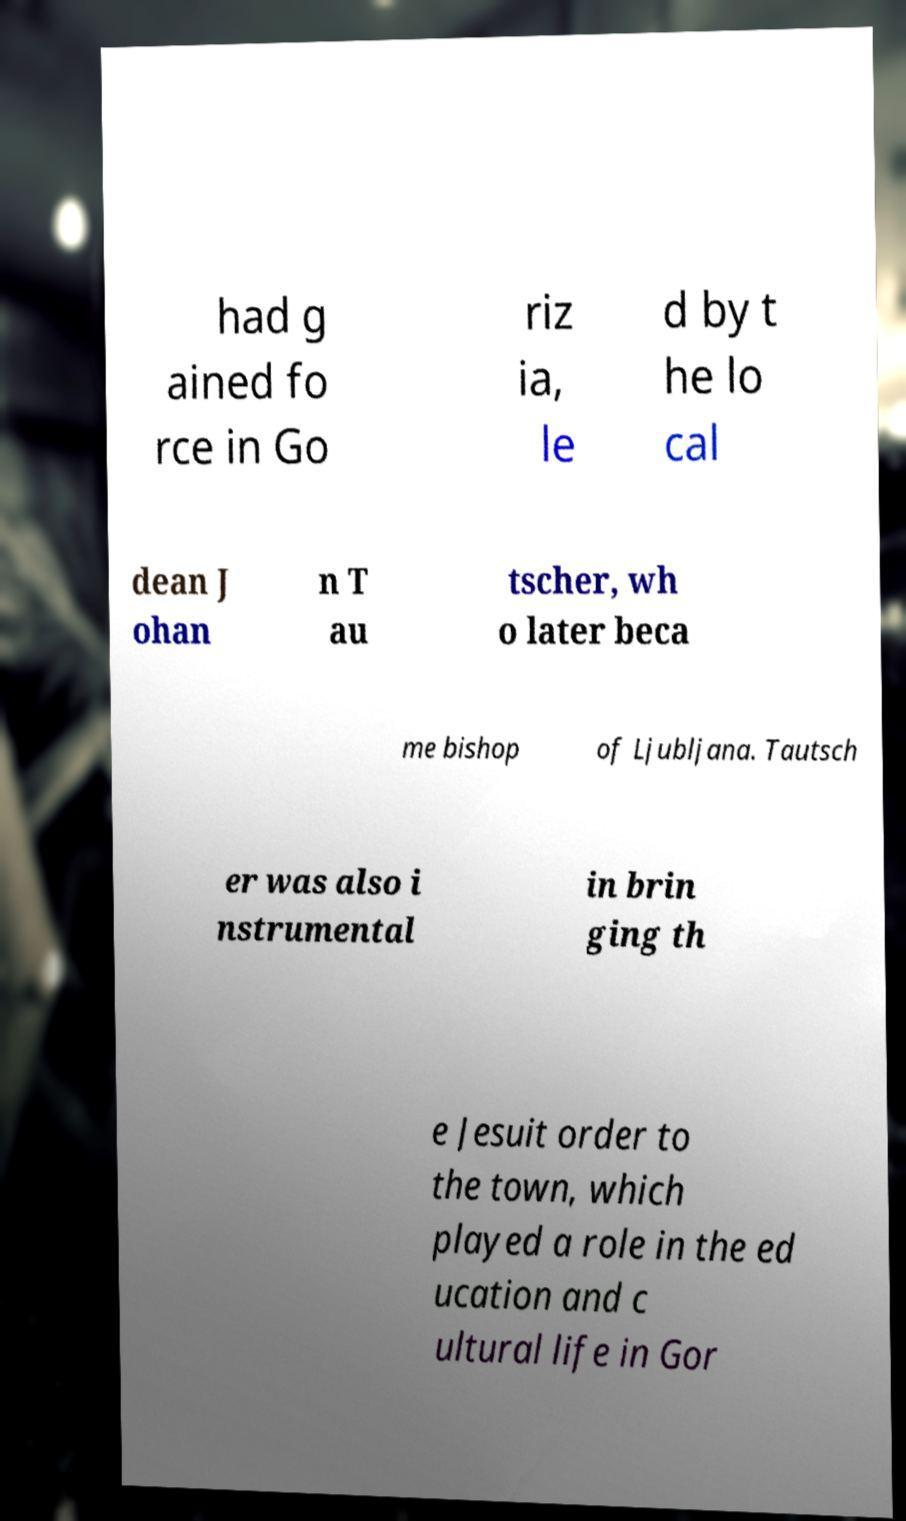Please identify and transcribe the text found in this image. had g ained fo rce in Go riz ia, le d by t he lo cal dean J ohan n T au tscher, wh o later beca me bishop of Ljubljana. Tautsch er was also i nstrumental in brin ging th e Jesuit order to the town, which played a role in the ed ucation and c ultural life in Gor 